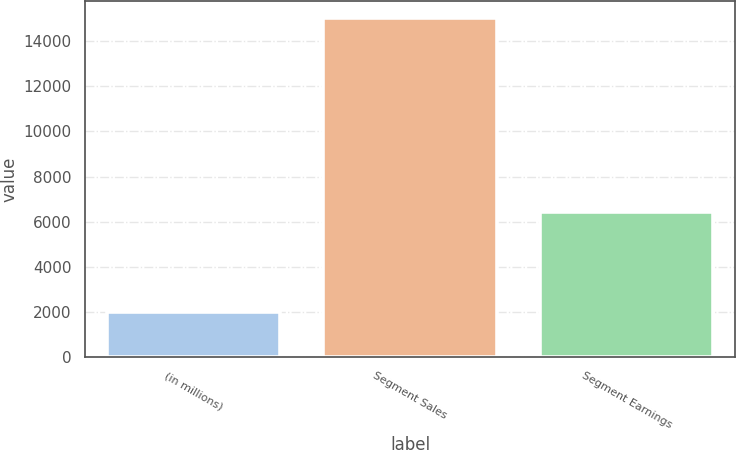Convert chart. <chart><loc_0><loc_0><loc_500><loc_500><bar_chart><fcel>(in millions)<fcel>Segment Sales<fcel>Segment Earnings<nl><fcel>2013<fcel>15008<fcel>6411<nl></chart> 